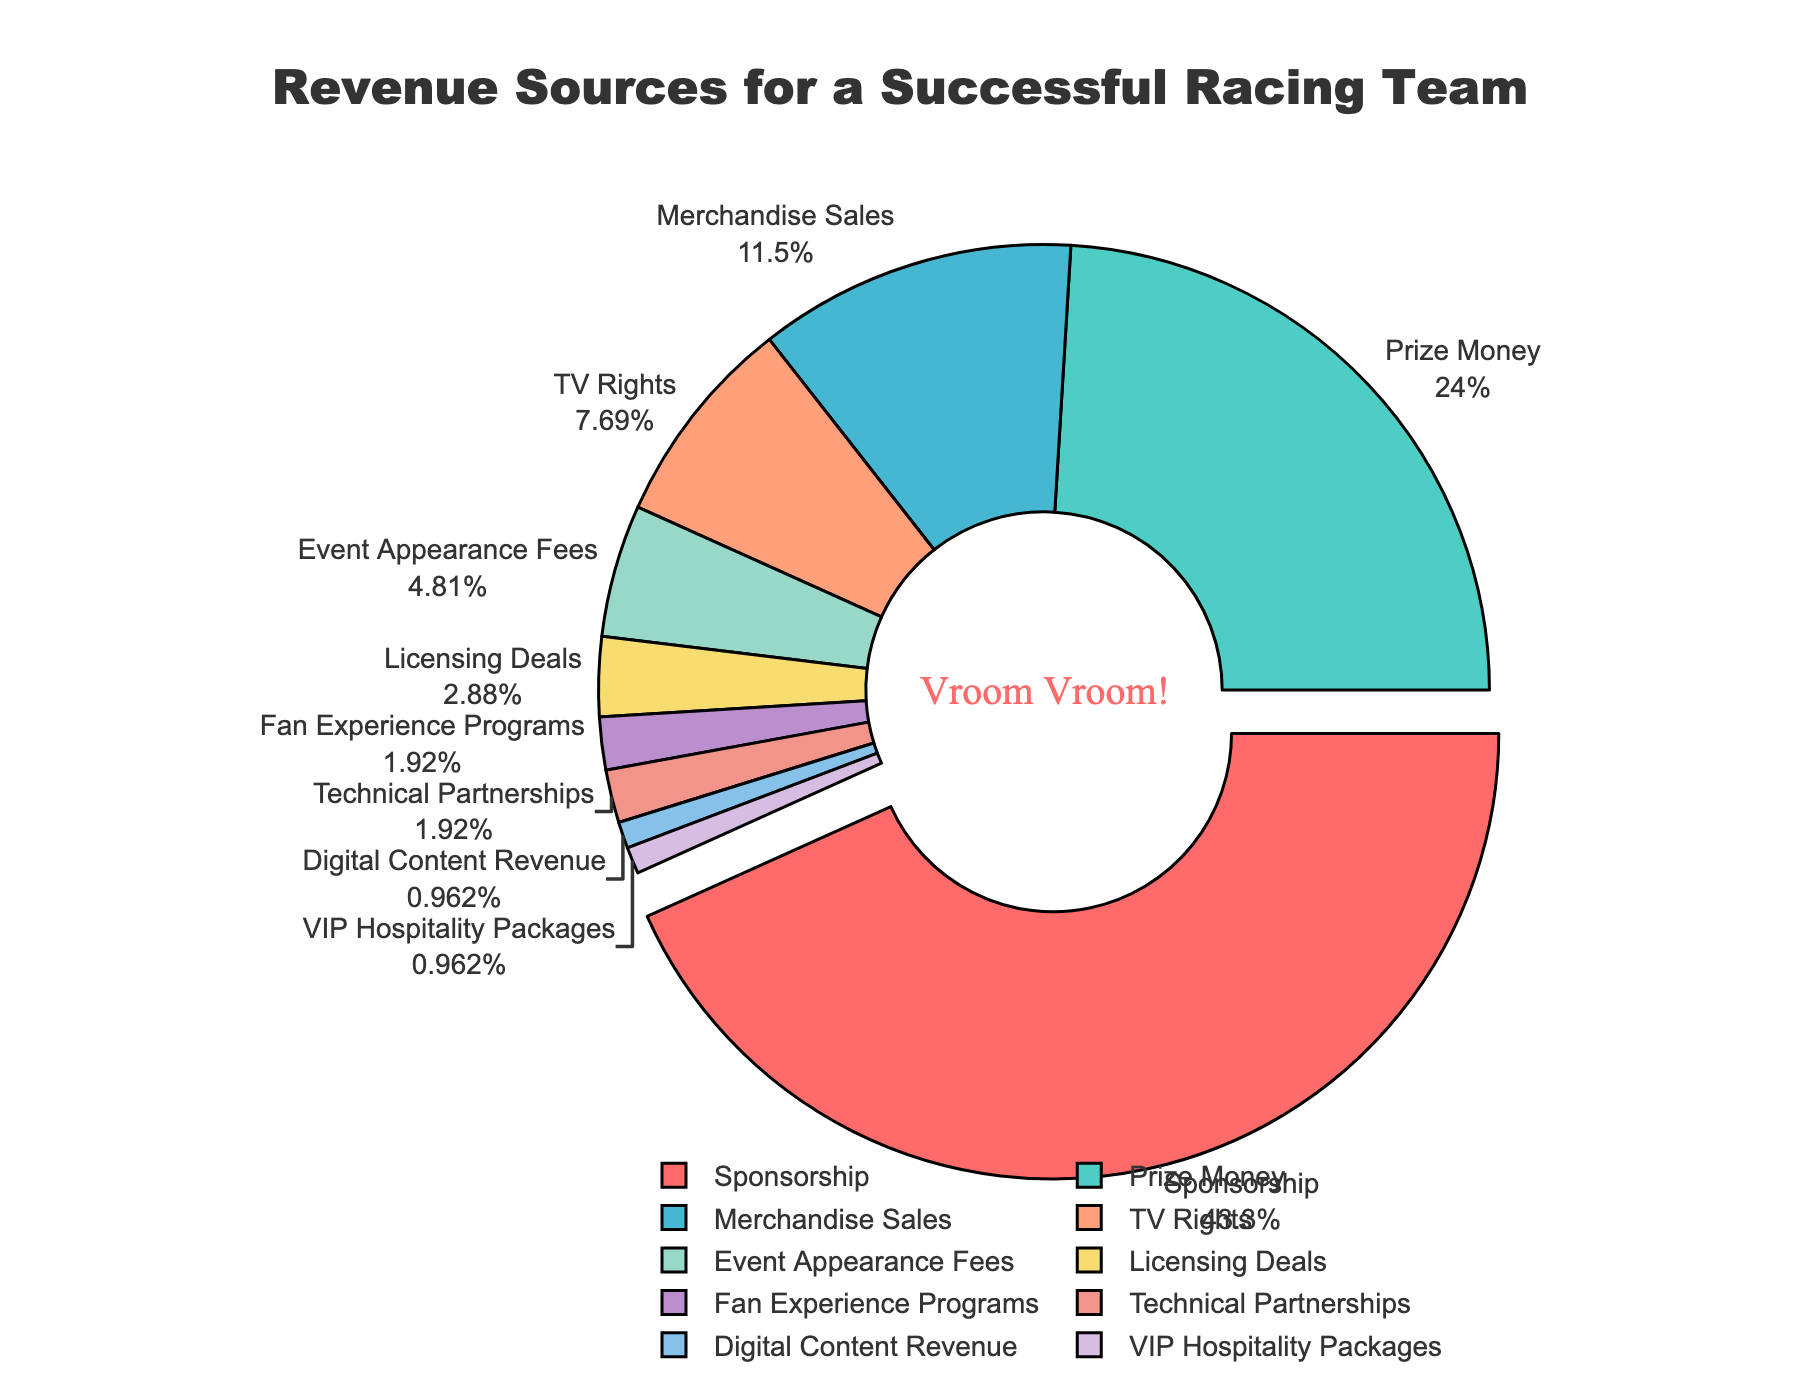What is the largest source of revenue for the racing team? By looking at the pie chart, the largest segment, which is pulled out slightly, represents the largest source of revenue. The label indicates this category is Sponsorship.
Answer: Sponsorship Which two sources combined contribute to over 50% of the revenue? By examining the chart, the largest segment is Sponsorship (45%) and the next largest is Prize Money (25%). Adding these percentages together: 45% + 25% = 70%, which is over 50%.
Answer: Sponsorship and Prize Money What is the second smallest source of revenue? The pie chart has segments ordered by size. The second smallest segment, just larger than the smallest one (VIP Hospitality Packages at 1%), is Digital Content Revenue at 1%.
Answer: Digital Content Revenue How much more revenue does Sponsorship generate compared to Merchandise Sales? The pie chart shows Sponsorship at 45% and Merchandise Sales at 12%. Subtracting these values: 45% - 12% = 33%.
Answer: 33% If you combined Event Appearance Fees, Licensing Deals, Fan Experience Programs, and Technical Partnerships, what percentage of the revenue would that be? The percentages for these categories are: Event Appearance Fees (5%), Licensing Deals (3%), Fan Experience Programs (2%), and Technical Partnerships (2%). Adding them together: 5% + 3% + 2% + 2% = 12%.
Answer: 12% Which revenue source contributes the least to the team's revenue? The pie chart shows the smallest segment, and the label for this segment indicates it is VIP Hospitality Packages at 1%.
Answer: VIP Hospitality Packages How does the revenue from TV Rights compare to that from Merchandise Sales? By comparing the two segments on the pie chart visually and checking the labels, TV Rights is 8%, and Merchandise Sales is 12%. Therefore, Merchandise Sales generates 4% more revenue than TV Rights.
Answer: Merchandise Sales generates more What is the total percentage of revenue from sources other than Sponsorship and Prize Money? First, add the percentages of Sponsorship (45%) and Prize Money (25%): 45% + 25% = 70%. Subtract this from 100%: 100% - 70% = 30%.
Answer: 30% Which sources have an equal contribution of 2% each? By examining the pie chart, the segments representing Fan Experience Programs and Technical Partnerships both show 2%.
Answer: Fan Experience Programs and Technical Partnerships How does the combined revenue from TV Rights and Event Appearance Fees compare to the revenue from Prize Money? TV Rights is 8% and Event Appearance Fees is 5%, giving a combined total of 8% + 5% = 13%. Prize Money alone is 25%, so Prize Money is 12% more than the combined total of TV Rights and Event Appearance Fees.
Answer: 12% more 